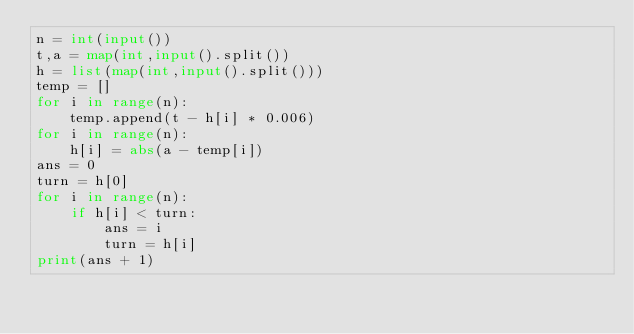<code> <loc_0><loc_0><loc_500><loc_500><_Python_>n = int(input())
t,a = map(int,input().split())
h = list(map(int,input().split()))
temp = []
for i in range(n):
    temp.append(t - h[i] * 0.006)
for i in range(n):
    h[i] = abs(a - temp[i])
ans = 0
turn = h[0]
for i in range(n):
    if h[i] < turn:
        ans = i
        turn = h[i]
print(ans + 1)</code> 